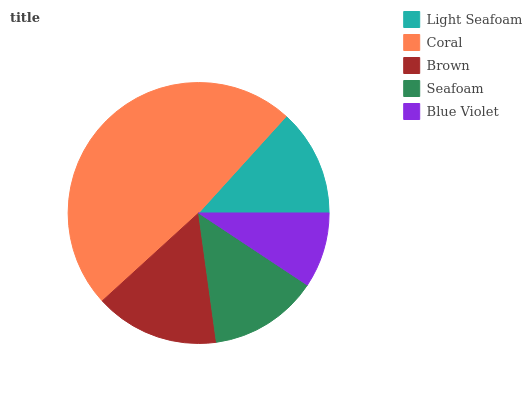Is Blue Violet the minimum?
Answer yes or no. Yes. Is Coral the maximum?
Answer yes or no. Yes. Is Brown the minimum?
Answer yes or no. No. Is Brown the maximum?
Answer yes or no. No. Is Coral greater than Brown?
Answer yes or no. Yes. Is Brown less than Coral?
Answer yes or no. Yes. Is Brown greater than Coral?
Answer yes or no. No. Is Coral less than Brown?
Answer yes or no. No. Is Seafoam the high median?
Answer yes or no. Yes. Is Seafoam the low median?
Answer yes or no. Yes. Is Blue Violet the high median?
Answer yes or no. No. Is Coral the low median?
Answer yes or no. No. 